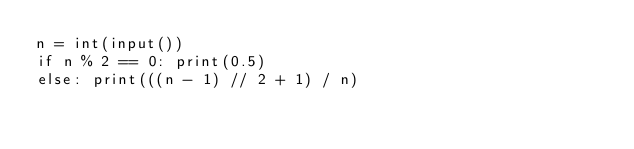Convert code to text. <code><loc_0><loc_0><loc_500><loc_500><_Python_>n = int(input())
if n % 2 == 0: print(0.5)
else: print(((n - 1) // 2 + 1) / n)</code> 